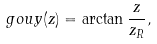<formula> <loc_0><loc_0><loc_500><loc_500>\ g o u y ( z ) = \arctan \frac { z } { z _ { R } } ,</formula> 